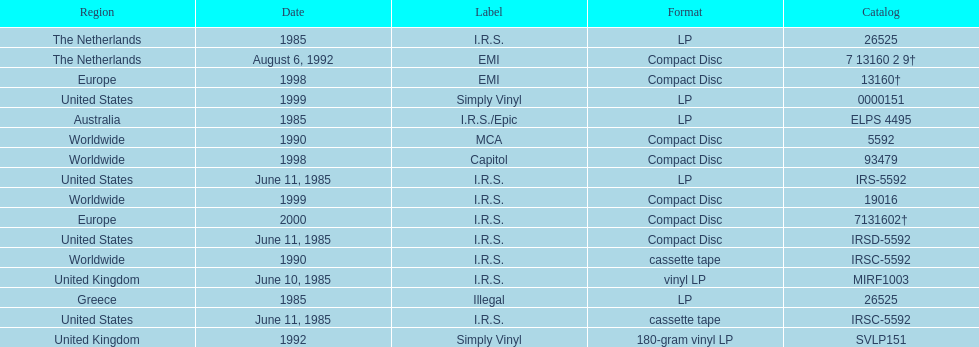How many more releases were in compact disc format than cassette tape? 5. Would you mind parsing the complete table? {'header': ['Region', 'Date', 'Label', 'Format', 'Catalog'], 'rows': [['The Netherlands', '1985', 'I.R.S.', 'LP', '26525'], ['The Netherlands', 'August 6, 1992', 'EMI', 'Compact Disc', '7 13160 2 9†'], ['Europe', '1998', 'EMI', 'Compact Disc', '13160†'], ['United States', '1999', 'Simply Vinyl', 'LP', '0000151'], ['Australia', '1985', 'I.R.S./Epic', 'LP', 'ELPS 4495'], ['Worldwide', '1990', 'MCA', 'Compact Disc', '5592'], ['Worldwide', '1998', 'Capitol', 'Compact Disc', '93479'], ['United States', 'June 11, 1985', 'I.R.S.', 'LP', 'IRS-5592'], ['Worldwide', '1999', 'I.R.S.', 'Compact Disc', '19016'], ['Europe', '2000', 'I.R.S.', 'Compact Disc', '7131602†'], ['United States', 'June 11, 1985', 'I.R.S.', 'Compact Disc', 'IRSD-5592'], ['Worldwide', '1990', 'I.R.S.', 'cassette tape', 'IRSC-5592'], ['United Kingdom', 'June 10, 1985', 'I.R.S.', 'vinyl LP', 'MIRF1003'], ['Greece', '1985', 'Illegal', 'LP', '26525'], ['United States', 'June 11, 1985', 'I.R.S.', 'cassette tape', 'IRSC-5592'], ['United Kingdom', '1992', 'Simply Vinyl', '180-gram vinyl LP', 'SVLP151']]} 